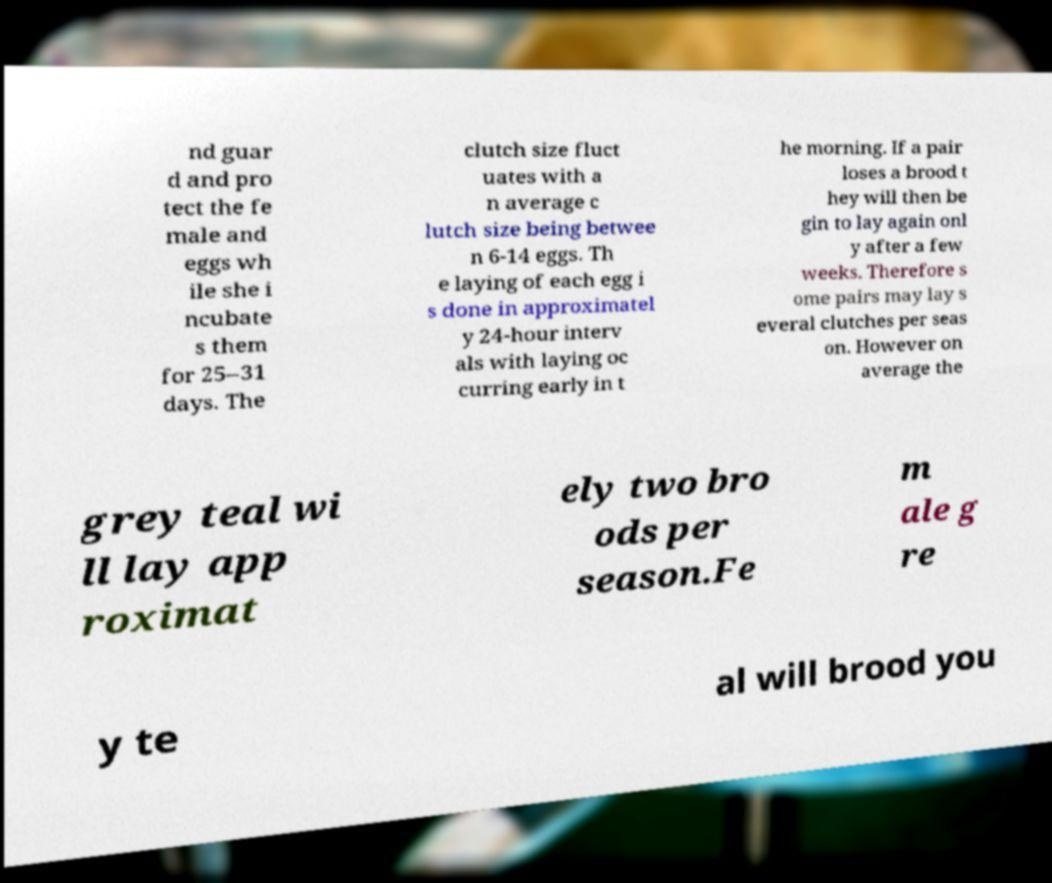Please read and relay the text visible in this image. What does it say? nd guar d and pro tect the fe male and eggs wh ile she i ncubate s them for 25–31 days. The clutch size fluct uates with a n average c lutch size being betwee n 6-14 eggs. Th e laying of each egg i s done in approximatel y 24-hour interv als with laying oc curring early in t he morning. If a pair loses a brood t hey will then be gin to lay again onl y after a few weeks. Therefore s ome pairs may lay s everal clutches per seas on. However on average the grey teal wi ll lay app roximat ely two bro ods per season.Fe m ale g re y te al will brood you 